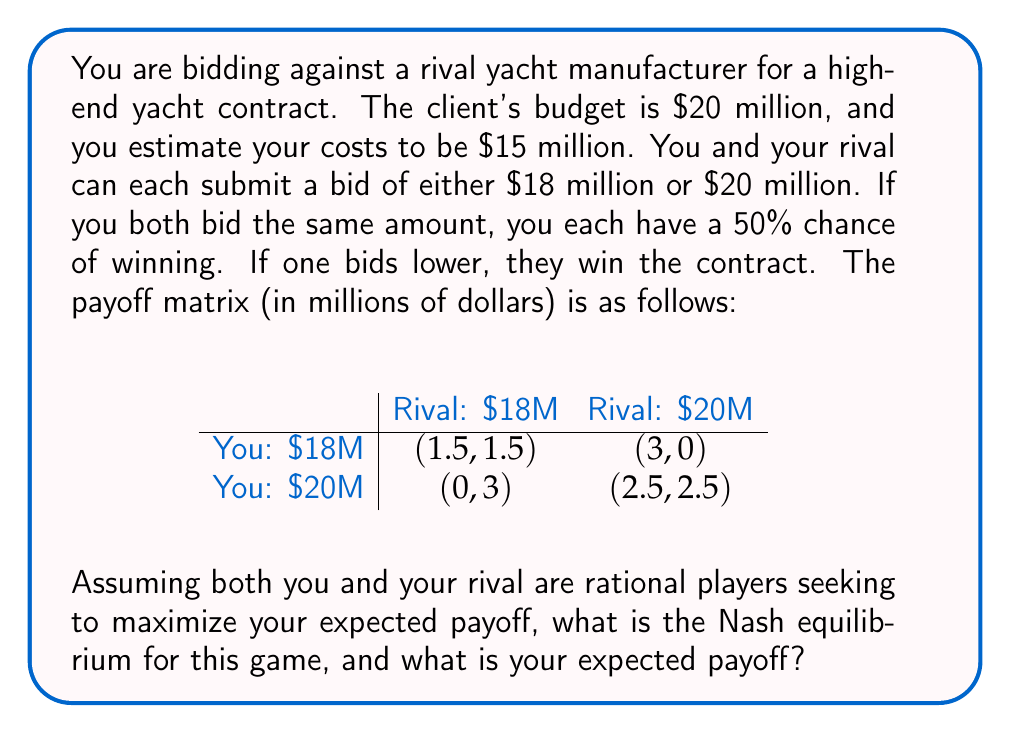Can you solve this math problem? To solve this problem, we need to find the Nash equilibrium of the game. A Nash equilibrium is a set of strategies where neither player can unilaterally improve their payoff by changing their strategy.

Let's analyze the game:

1) First, check for pure strategy Nash equilibria:
   - If you bid $18M and your rival bids $18M, you both get $1.5M. Neither wants to switch to $20M.
   - If you bid $18M and your rival bids $20M, you get $3M and they get $0M. The rival would want to switch to $18M.
   - If you bid $20M and your rival bids $18M, you get $0M and they get $3M. You would want to switch to $18M.
   - If you bid $20M and your rival bids $20M, you both get $2.5M. Both would want to switch to $18M.

There is no pure strategy Nash equilibrium.

2) Now, let's look for a mixed strategy Nash equilibrium:
   Let $p$ be the probability that you bid $18M, and $q$ be the probability that your rival bids $18M.

3) For your rival to be indifferent between their strategies:
   $$1.5q + 3(1-q) = 0q + 2.5(1-q)$$
   $$1.5q + 3 - 3q = 2.5 - 2.5q$$
   $$3 - 1.5q = 2.5 - 2.5q$$
   $$0.5 = q$$

4) Similarly, for you to be indifferent:
   $$1.5p + 0(1-p) = 3p + 2.5(1-p)$$
   $$1.5p = 3p + 2.5 - 2.5p$$
   $$2.5 = 4p$$
   $$p = 0.625$$

5) The Nash equilibrium is for you to bid $18M with probability 0.625 and $20M with probability 0.375, and for your rival to bid $18M with probability 0.5 and $20M with probability 0.5.

6) To calculate your expected payoff:
   $$E = 0.625 \cdot 0.5 \cdot 1.5 + 0.625 \cdot 0.5 \cdot 3 + 0.375 \cdot 0.5 \cdot 0 + 0.375 \cdot 0.5 \cdot 2.5$$
   $$E = 0.46875 + 0.9375 + 0 + 0.46875 = 1.875$$

Therefore, your expected payoff is $1.875 million.
Answer: The Nash equilibrium is a mixed strategy where you bid $18M with probability 0.625 and $20M with probability 0.375, and your rival bids $18M with probability 0.5 and $20M with probability 0.5. Your expected payoff is $1.875 million. 